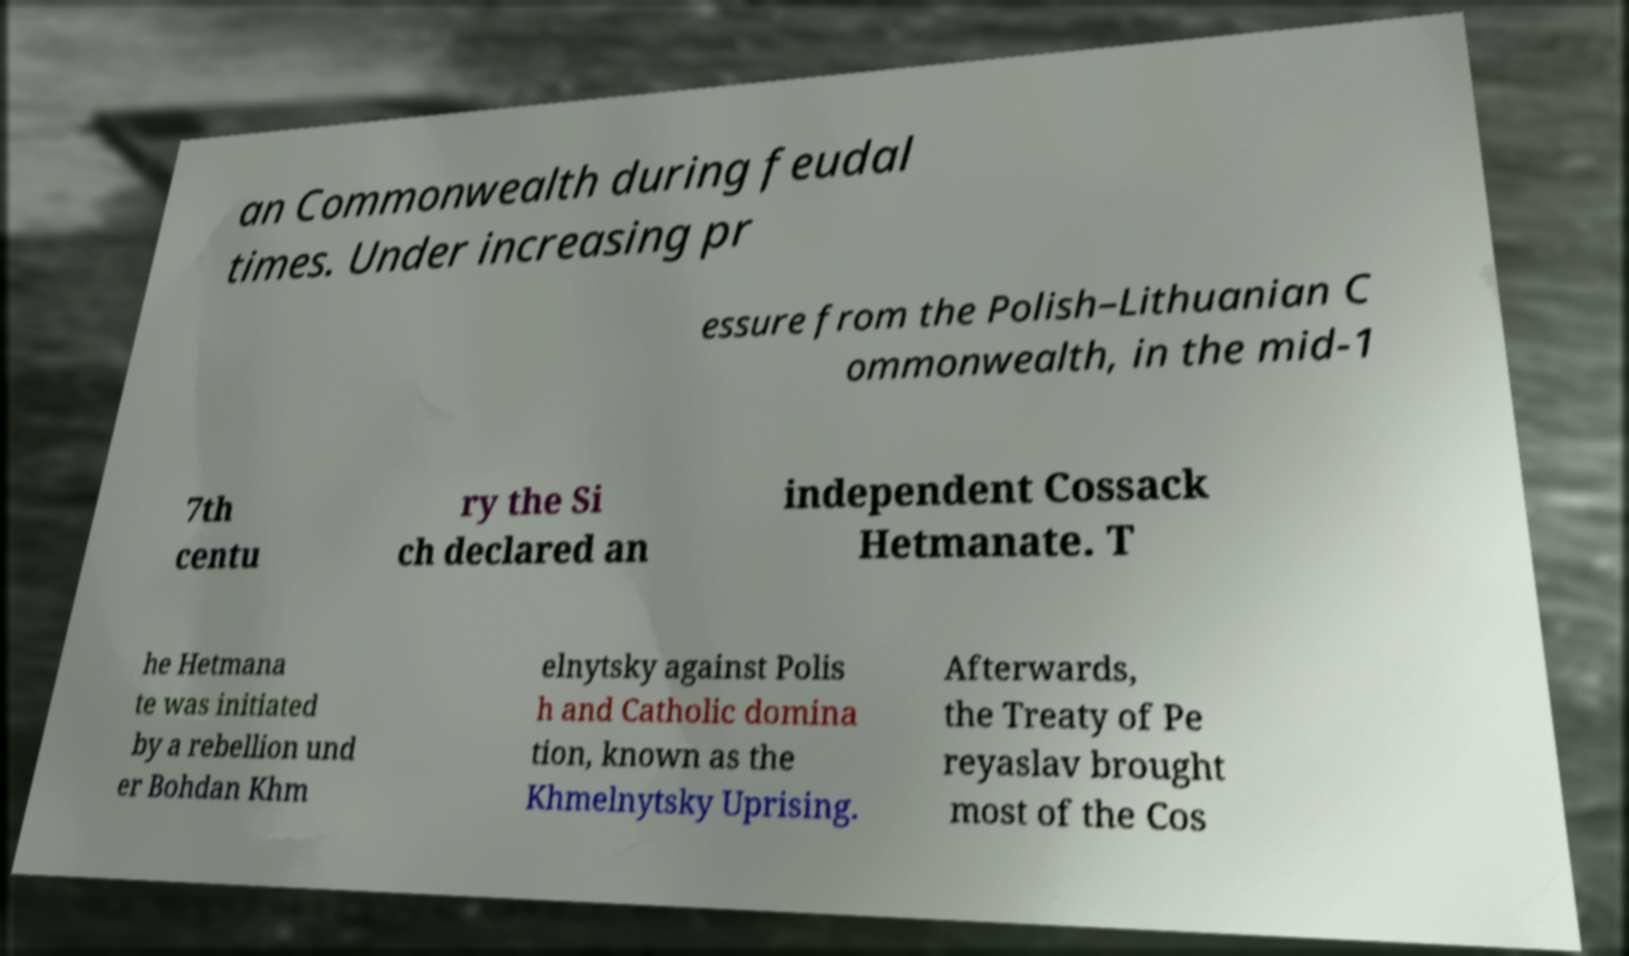There's text embedded in this image that I need extracted. Can you transcribe it verbatim? an Commonwealth during feudal times. Under increasing pr essure from the Polish–Lithuanian C ommonwealth, in the mid-1 7th centu ry the Si ch declared an independent Cossack Hetmanate. T he Hetmana te was initiated by a rebellion und er Bohdan Khm elnytsky against Polis h and Catholic domina tion, known as the Khmelnytsky Uprising. Afterwards, the Treaty of Pe reyaslav brought most of the Cos 